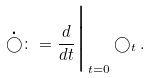Convert formula to latex. <formula><loc_0><loc_0><loc_500><loc_500>\mathop \bigcirc ^ { \centerdot } \colon = \frac { d } { d t } \Big | _ { t = 0 } \bigcirc _ { t } .</formula> 